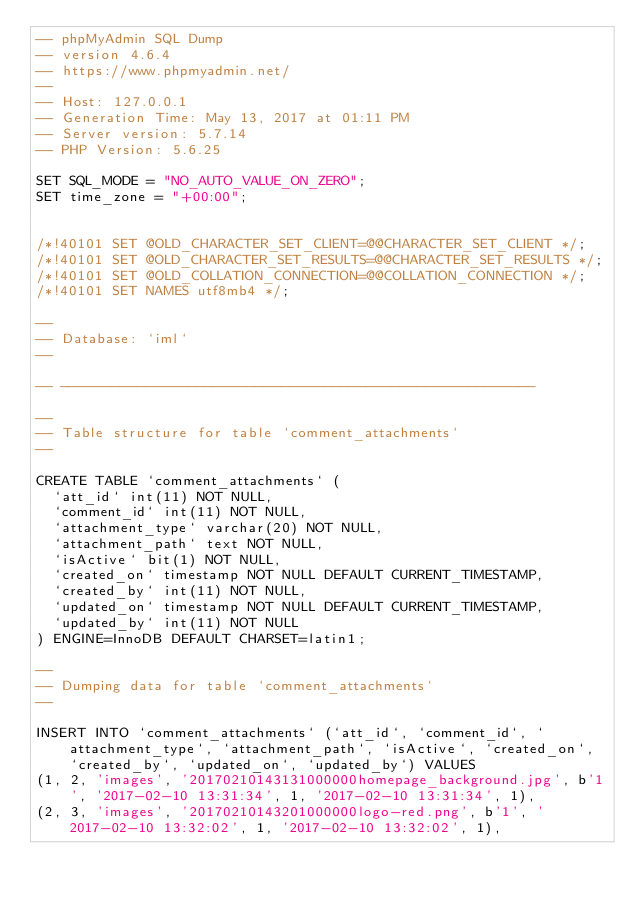<code> <loc_0><loc_0><loc_500><loc_500><_SQL_>-- phpMyAdmin SQL Dump
-- version 4.6.4
-- https://www.phpmyadmin.net/
--
-- Host: 127.0.0.1
-- Generation Time: May 13, 2017 at 01:11 PM
-- Server version: 5.7.14
-- PHP Version: 5.6.25

SET SQL_MODE = "NO_AUTO_VALUE_ON_ZERO";
SET time_zone = "+00:00";


/*!40101 SET @OLD_CHARACTER_SET_CLIENT=@@CHARACTER_SET_CLIENT */;
/*!40101 SET @OLD_CHARACTER_SET_RESULTS=@@CHARACTER_SET_RESULTS */;
/*!40101 SET @OLD_COLLATION_CONNECTION=@@COLLATION_CONNECTION */;
/*!40101 SET NAMES utf8mb4 */;

--
-- Database: `iml`
--

-- --------------------------------------------------------

--
-- Table structure for table `comment_attachments`
--

CREATE TABLE `comment_attachments` (
  `att_id` int(11) NOT NULL,
  `comment_id` int(11) NOT NULL,
  `attachment_type` varchar(20) NOT NULL,
  `attachment_path` text NOT NULL,
  `isActive` bit(1) NOT NULL,
  `created_on` timestamp NOT NULL DEFAULT CURRENT_TIMESTAMP,
  `created_by` int(11) NOT NULL,
  `updated_on` timestamp NOT NULL DEFAULT CURRENT_TIMESTAMP,
  `updated_by` int(11) NOT NULL
) ENGINE=InnoDB DEFAULT CHARSET=latin1;

--
-- Dumping data for table `comment_attachments`
--

INSERT INTO `comment_attachments` (`att_id`, `comment_id`, `attachment_type`, `attachment_path`, `isActive`, `created_on`, `created_by`, `updated_on`, `updated_by`) VALUES
(1, 2, 'images', '20170210143131000000homepage_background.jpg', b'1', '2017-02-10 13:31:34', 1, '2017-02-10 13:31:34', 1),
(2, 3, 'images', '20170210143201000000logo-red.png', b'1', '2017-02-10 13:32:02', 1, '2017-02-10 13:32:02', 1),</code> 